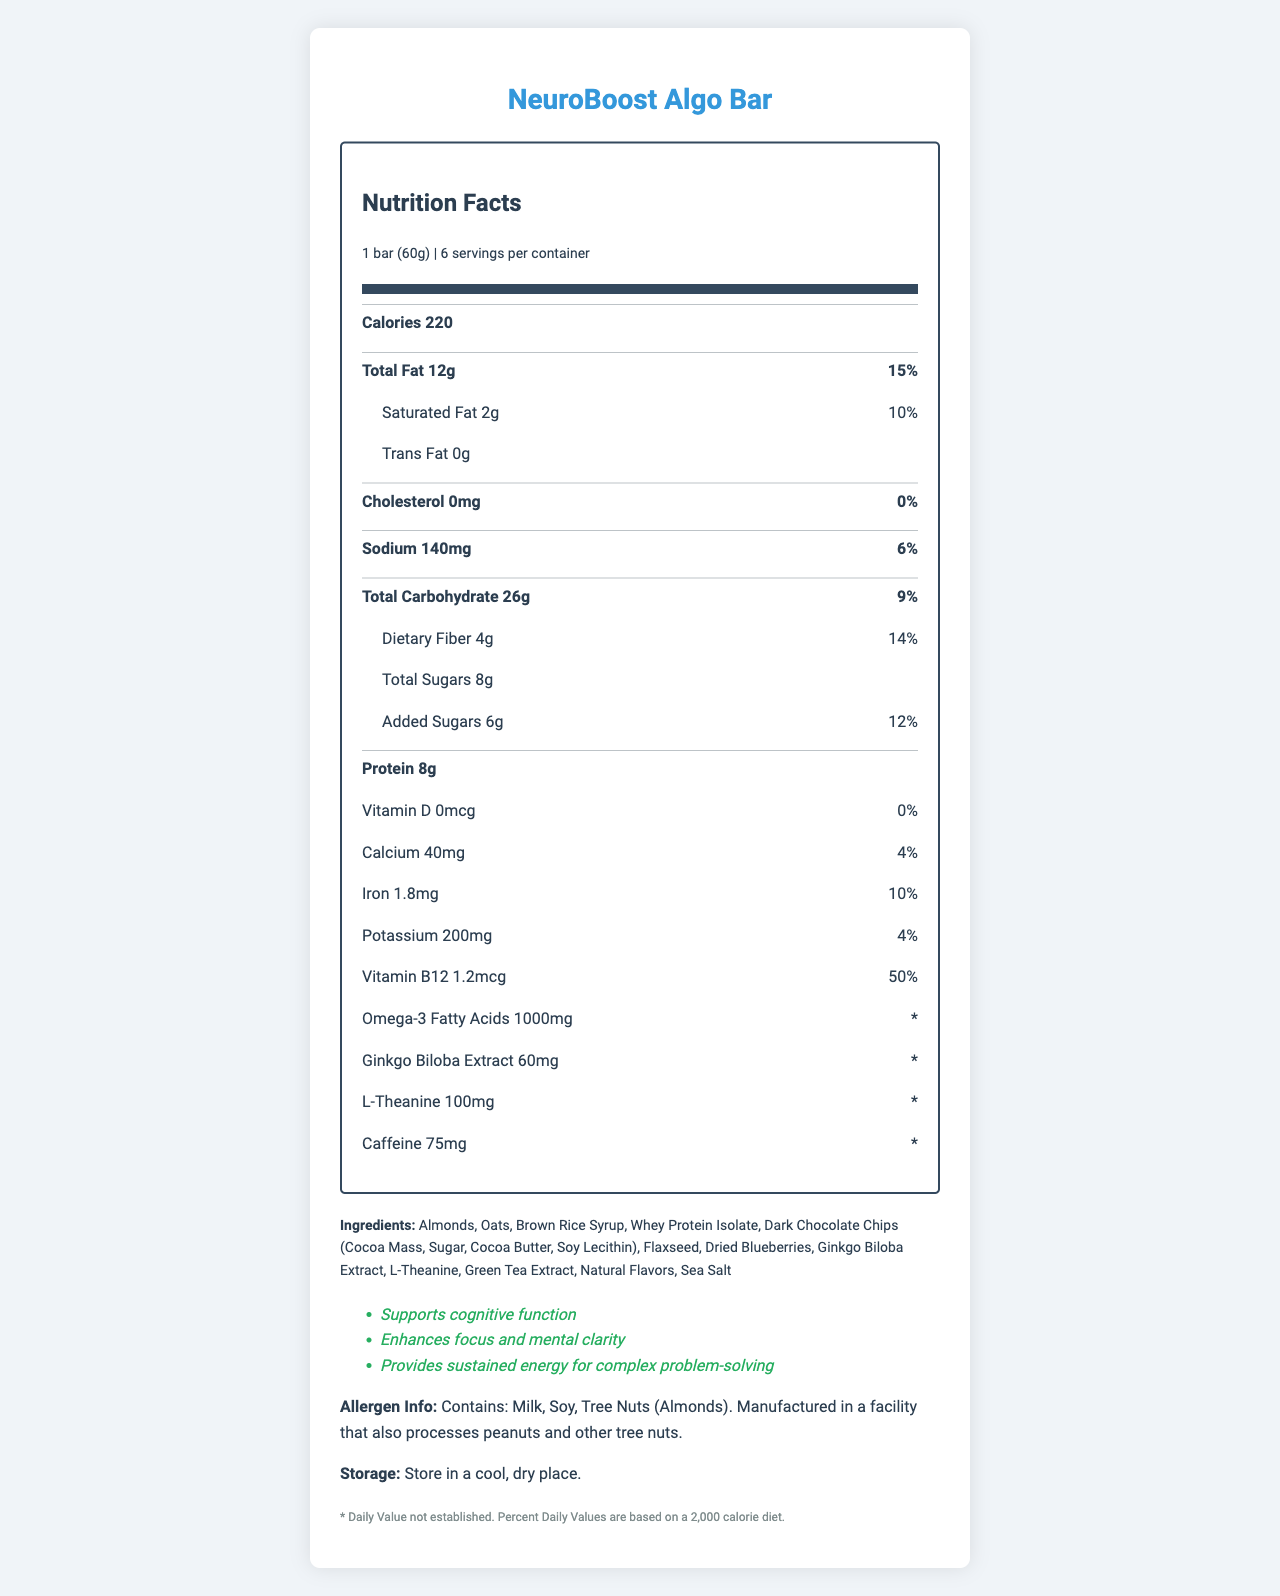what is the serving size? The serving size is explicitly mentioned as "1 bar (60g)" in the serving info section.
Answer: 1 bar (60g) how many servings are there per container? The document states that there are 6 servings per container.
Answer: 6 how many calories are there in one serving? The document lists the calorie content as 220 per serving.
Answer: 220 calories what is the total fat content per serving? The document mentions that each serving has 12g of total fat.
Answer: 12g how much dietary fiber does one bar contain? The document specifies that there is 4g of dietary fiber per serving.
Answer: 4g what vitamin has the highest daily value percentage in this product? The document shows Vitamin B12 at 50% daily value, which is higher than the other vitamins and minerals listed.
Answer: Vitamin B12 what ingredients are used in the NeuroBoost Algo Bar? The document lists all these ingredients in the ingredients section.
Answer: Almonds, Oats, Brown Rice Syrup, Whey Protein Isolate, Dark Chocolate Chips (Cocoa Mass, Sugar, Cocoa Butter, Soy Lecithin), Flaxseed, Dried Blueberries, Ginkgo Biloba Extract, L-Theanine, Green Tea Extract, Natural Flavors, Sea Salt what special claims does this product make? The document includes these claims in the claims section.
Answer: Supports cognitive function, Enhances focus and mental clarity, Provides sustained energy for complex problem-solving what allergens does the product contain? The allergen information is stated as containing milk, soy, and tree nuts (almonds).
Answer: Milk, Soy, Tree Nuts (Almonds) the product is high in which nutrient? A. Vitamin D B. Iron C. Vitamin B12 Vitamin B12 at 50% daily value is the highest compared to iron (10%) and vitamin D (0%).
Answer: C how much cholesterol is in each serving? A. 0mg B. 10mg C. 20mg D. 50mg The document states that the cholesterol content is 0mg per serving.
Answer: A does this product contain trans fat? The document clearly lists trans fat content as 0g.
Answer: No does the product provide calcium? The document lists calcium content as 40mg per serving.
Answer: Yes summarize the main features and nutritional information of the NeuroBoost Algo Bar. The summary encapsulates the key nutritional data, ingredients, cognitive function claims, and allergen information specified in the document.
Answer: The NeuroBoost Algo Bar is designed to support cognitive function, enhance focus and mental clarity, and provide sustained energy for complex problem-solving. Each bar (60g) offers 220 calories, 12g of total fat, 26g of carbohydrates, 8g of protein, and is rich in Vitamin B12 (50% daily value). It contains special ingredients like Omega-3 Fatty Acids, Ginkgo Biloba Extract, L-Theanine, and caffeine. The bar is made with almonds, oats, brown rice syrup, whey protein isolate, dark chocolate chips, flaxseed, dried blueberries, and natural flavors, but it contains allergens like milk, soy, and tree nuts. what is the price of the product per container? The document does not provide any pricing information, so this cannot be determined.
Answer: Cannot be determined 